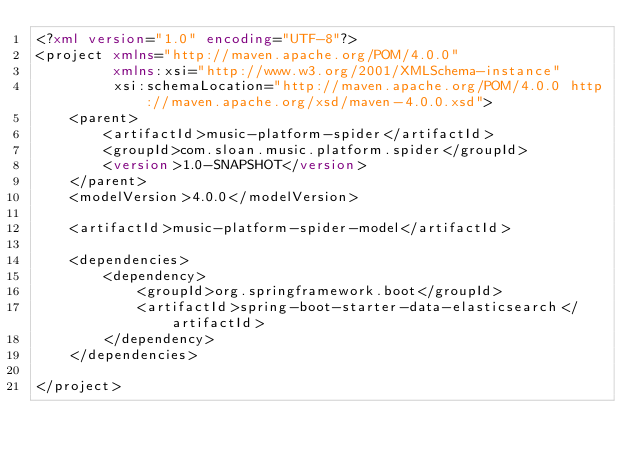Convert code to text. <code><loc_0><loc_0><loc_500><loc_500><_XML_><?xml version="1.0" encoding="UTF-8"?>
<project xmlns="http://maven.apache.org/POM/4.0.0"
         xmlns:xsi="http://www.w3.org/2001/XMLSchema-instance"
         xsi:schemaLocation="http://maven.apache.org/POM/4.0.0 http://maven.apache.org/xsd/maven-4.0.0.xsd">
    <parent>
        <artifactId>music-platform-spider</artifactId>
        <groupId>com.sloan.music.platform.spider</groupId>
        <version>1.0-SNAPSHOT</version>
    </parent>
    <modelVersion>4.0.0</modelVersion>

    <artifactId>music-platform-spider-model</artifactId>

    <dependencies>
        <dependency>
            <groupId>org.springframework.boot</groupId>
            <artifactId>spring-boot-starter-data-elasticsearch</artifactId>
        </dependency>
    </dependencies>

</project></code> 